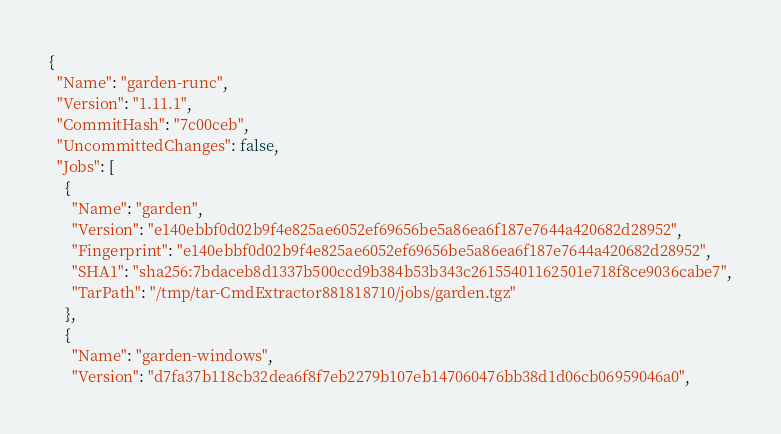Convert code to text. <code><loc_0><loc_0><loc_500><loc_500><_YAML_>{
  "Name": "garden-runc",
  "Version": "1.11.1",
  "CommitHash": "7c00ceb",
  "UncommittedChanges": false,
  "Jobs": [
    {
      "Name": "garden",
      "Version": "e140ebbf0d02b9f4e825ae6052ef69656be5a86ea6f187e7644a420682d28952",
      "Fingerprint": "e140ebbf0d02b9f4e825ae6052ef69656be5a86ea6f187e7644a420682d28952",
      "SHA1": "sha256:7bdaceb8d1337b500ccd9b384b53b343c26155401162501e718f8ce9036cabe7",
      "TarPath": "/tmp/tar-CmdExtractor881818710/jobs/garden.tgz"
    },
    {
      "Name": "garden-windows",
      "Version": "d7fa37b118cb32dea6f8f7eb2279b107eb147060476bb38d1d06cb06959046a0",</code> 